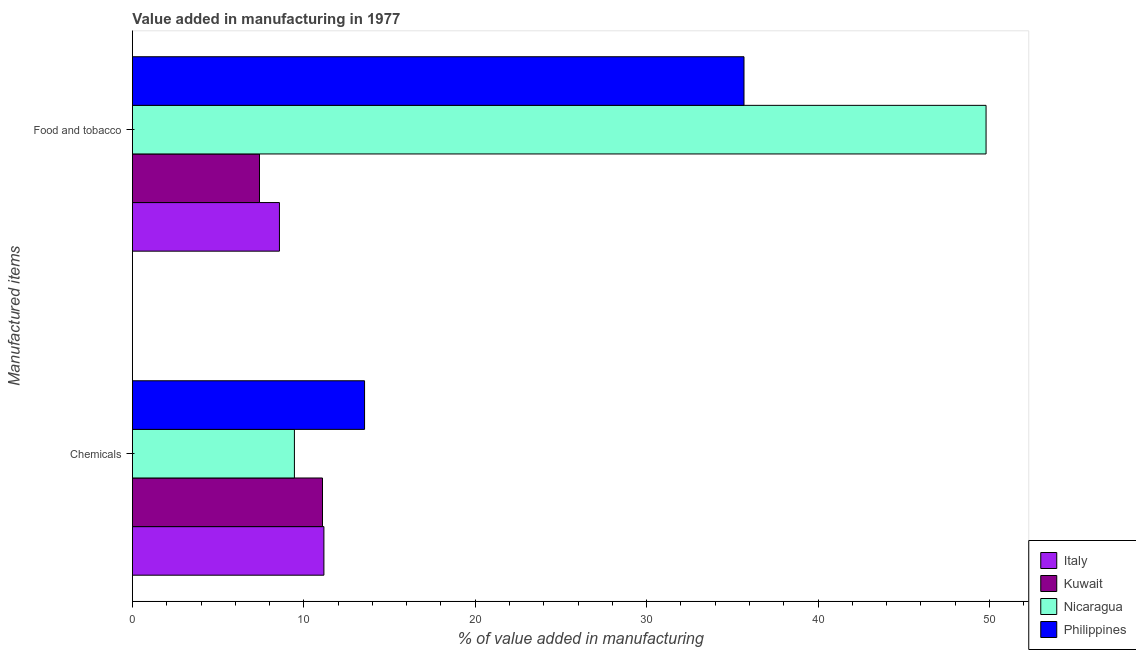Are the number of bars on each tick of the Y-axis equal?
Your response must be concise. Yes. How many bars are there on the 1st tick from the top?
Keep it short and to the point. 4. What is the label of the 2nd group of bars from the top?
Your response must be concise. Chemicals. What is the value added by manufacturing food and tobacco in Nicaragua?
Offer a very short reply. 49.8. Across all countries, what is the maximum value added by manufacturing food and tobacco?
Your answer should be very brief. 49.8. Across all countries, what is the minimum value added by manufacturing food and tobacco?
Make the answer very short. 7.41. In which country was the value added by  manufacturing chemicals maximum?
Offer a very short reply. Philippines. In which country was the value added by  manufacturing chemicals minimum?
Keep it short and to the point. Nicaragua. What is the total value added by manufacturing food and tobacco in the graph?
Give a very brief answer. 101.47. What is the difference between the value added by  manufacturing chemicals in Philippines and that in Nicaragua?
Provide a succinct answer. 4.09. What is the difference between the value added by  manufacturing chemicals in Italy and the value added by manufacturing food and tobacco in Philippines?
Keep it short and to the point. -24.51. What is the average value added by  manufacturing chemicals per country?
Offer a very short reply. 11.31. What is the difference between the value added by manufacturing food and tobacco and value added by  manufacturing chemicals in Kuwait?
Ensure brevity in your answer.  -3.68. In how many countries, is the value added by  manufacturing chemicals greater than 18 %?
Offer a very short reply. 0. What is the ratio of the value added by  manufacturing chemicals in Philippines to that in Kuwait?
Offer a very short reply. 1.22. Is the value added by manufacturing food and tobacco in Philippines less than that in Nicaragua?
Offer a very short reply. Yes. In how many countries, is the value added by manufacturing food and tobacco greater than the average value added by manufacturing food and tobacco taken over all countries?
Your answer should be very brief. 2. What does the 2nd bar from the top in Food and tobacco represents?
Make the answer very short. Nicaragua. What does the 3rd bar from the bottom in Food and tobacco represents?
Offer a very short reply. Nicaragua. How many bars are there?
Provide a short and direct response. 8. What is the difference between two consecutive major ticks on the X-axis?
Offer a very short reply. 10. Does the graph contain any zero values?
Make the answer very short. No. Does the graph contain grids?
Your answer should be compact. No. Where does the legend appear in the graph?
Your response must be concise. Bottom right. How many legend labels are there?
Provide a succinct answer. 4. What is the title of the graph?
Keep it short and to the point. Value added in manufacturing in 1977. Does "European Union" appear as one of the legend labels in the graph?
Make the answer very short. No. What is the label or title of the X-axis?
Provide a succinct answer. % of value added in manufacturing. What is the label or title of the Y-axis?
Your answer should be very brief. Manufactured items. What is the % of value added in manufacturing in Italy in Chemicals?
Offer a terse response. 11.17. What is the % of value added in manufacturing of Kuwait in Chemicals?
Ensure brevity in your answer.  11.09. What is the % of value added in manufacturing in Nicaragua in Chemicals?
Offer a terse response. 9.45. What is the % of value added in manufacturing of Philippines in Chemicals?
Offer a terse response. 13.54. What is the % of value added in manufacturing in Italy in Food and tobacco?
Provide a succinct answer. 8.58. What is the % of value added in manufacturing in Kuwait in Food and tobacco?
Provide a short and direct response. 7.41. What is the % of value added in manufacturing in Nicaragua in Food and tobacco?
Provide a short and direct response. 49.8. What is the % of value added in manufacturing in Philippines in Food and tobacco?
Ensure brevity in your answer.  35.68. Across all Manufactured items, what is the maximum % of value added in manufacturing in Italy?
Provide a succinct answer. 11.17. Across all Manufactured items, what is the maximum % of value added in manufacturing in Kuwait?
Ensure brevity in your answer.  11.09. Across all Manufactured items, what is the maximum % of value added in manufacturing in Nicaragua?
Ensure brevity in your answer.  49.8. Across all Manufactured items, what is the maximum % of value added in manufacturing of Philippines?
Make the answer very short. 35.68. Across all Manufactured items, what is the minimum % of value added in manufacturing in Italy?
Your response must be concise. 8.58. Across all Manufactured items, what is the minimum % of value added in manufacturing in Kuwait?
Offer a very short reply. 7.41. Across all Manufactured items, what is the minimum % of value added in manufacturing of Nicaragua?
Give a very brief answer. 9.45. Across all Manufactured items, what is the minimum % of value added in manufacturing of Philippines?
Ensure brevity in your answer.  13.54. What is the total % of value added in manufacturing in Italy in the graph?
Offer a terse response. 19.75. What is the total % of value added in manufacturing of Kuwait in the graph?
Your answer should be compact. 18.5. What is the total % of value added in manufacturing of Nicaragua in the graph?
Your answer should be very brief. 59.25. What is the total % of value added in manufacturing in Philippines in the graph?
Give a very brief answer. 49.22. What is the difference between the % of value added in manufacturing of Italy in Chemicals and that in Food and tobacco?
Offer a terse response. 2.59. What is the difference between the % of value added in manufacturing of Kuwait in Chemicals and that in Food and tobacco?
Give a very brief answer. 3.68. What is the difference between the % of value added in manufacturing in Nicaragua in Chemicals and that in Food and tobacco?
Keep it short and to the point. -40.35. What is the difference between the % of value added in manufacturing of Philippines in Chemicals and that in Food and tobacco?
Your answer should be very brief. -22.14. What is the difference between the % of value added in manufacturing of Italy in Chemicals and the % of value added in manufacturing of Kuwait in Food and tobacco?
Offer a terse response. 3.76. What is the difference between the % of value added in manufacturing in Italy in Chemicals and the % of value added in manufacturing in Nicaragua in Food and tobacco?
Offer a very short reply. -38.63. What is the difference between the % of value added in manufacturing of Italy in Chemicals and the % of value added in manufacturing of Philippines in Food and tobacco?
Give a very brief answer. -24.51. What is the difference between the % of value added in manufacturing in Kuwait in Chemicals and the % of value added in manufacturing in Nicaragua in Food and tobacco?
Offer a very short reply. -38.71. What is the difference between the % of value added in manufacturing of Kuwait in Chemicals and the % of value added in manufacturing of Philippines in Food and tobacco?
Your answer should be very brief. -24.59. What is the difference between the % of value added in manufacturing of Nicaragua in Chemicals and the % of value added in manufacturing of Philippines in Food and tobacco?
Provide a succinct answer. -26.23. What is the average % of value added in manufacturing in Italy per Manufactured items?
Keep it short and to the point. 9.87. What is the average % of value added in manufacturing in Kuwait per Manufactured items?
Provide a succinct answer. 9.25. What is the average % of value added in manufacturing of Nicaragua per Manufactured items?
Offer a terse response. 29.62. What is the average % of value added in manufacturing of Philippines per Manufactured items?
Your response must be concise. 24.61. What is the difference between the % of value added in manufacturing in Italy and % of value added in manufacturing in Kuwait in Chemicals?
Give a very brief answer. 0.08. What is the difference between the % of value added in manufacturing in Italy and % of value added in manufacturing in Nicaragua in Chemicals?
Keep it short and to the point. 1.72. What is the difference between the % of value added in manufacturing in Italy and % of value added in manufacturing in Philippines in Chemicals?
Make the answer very short. -2.37. What is the difference between the % of value added in manufacturing in Kuwait and % of value added in manufacturing in Nicaragua in Chemicals?
Keep it short and to the point. 1.64. What is the difference between the % of value added in manufacturing in Kuwait and % of value added in manufacturing in Philippines in Chemicals?
Your answer should be very brief. -2.45. What is the difference between the % of value added in manufacturing of Nicaragua and % of value added in manufacturing of Philippines in Chemicals?
Your answer should be very brief. -4.09. What is the difference between the % of value added in manufacturing in Italy and % of value added in manufacturing in Kuwait in Food and tobacco?
Ensure brevity in your answer.  1.16. What is the difference between the % of value added in manufacturing of Italy and % of value added in manufacturing of Nicaragua in Food and tobacco?
Give a very brief answer. -41.22. What is the difference between the % of value added in manufacturing in Italy and % of value added in manufacturing in Philippines in Food and tobacco?
Your response must be concise. -27.1. What is the difference between the % of value added in manufacturing in Kuwait and % of value added in manufacturing in Nicaragua in Food and tobacco?
Your response must be concise. -42.39. What is the difference between the % of value added in manufacturing of Kuwait and % of value added in manufacturing of Philippines in Food and tobacco?
Your answer should be very brief. -28.27. What is the difference between the % of value added in manufacturing in Nicaragua and % of value added in manufacturing in Philippines in Food and tobacco?
Make the answer very short. 14.12. What is the ratio of the % of value added in manufacturing of Italy in Chemicals to that in Food and tobacco?
Your answer should be compact. 1.3. What is the ratio of the % of value added in manufacturing in Kuwait in Chemicals to that in Food and tobacco?
Give a very brief answer. 1.5. What is the ratio of the % of value added in manufacturing of Nicaragua in Chemicals to that in Food and tobacco?
Your response must be concise. 0.19. What is the ratio of the % of value added in manufacturing of Philippines in Chemicals to that in Food and tobacco?
Offer a very short reply. 0.38. What is the difference between the highest and the second highest % of value added in manufacturing in Italy?
Ensure brevity in your answer.  2.59. What is the difference between the highest and the second highest % of value added in manufacturing of Kuwait?
Your answer should be very brief. 3.68. What is the difference between the highest and the second highest % of value added in manufacturing in Nicaragua?
Make the answer very short. 40.35. What is the difference between the highest and the second highest % of value added in manufacturing of Philippines?
Keep it short and to the point. 22.14. What is the difference between the highest and the lowest % of value added in manufacturing of Italy?
Offer a terse response. 2.59. What is the difference between the highest and the lowest % of value added in manufacturing in Kuwait?
Give a very brief answer. 3.68. What is the difference between the highest and the lowest % of value added in manufacturing of Nicaragua?
Offer a very short reply. 40.35. What is the difference between the highest and the lowest % of value added in manufacturing of Philippines?
Provide a short and direct response. 22.14. 